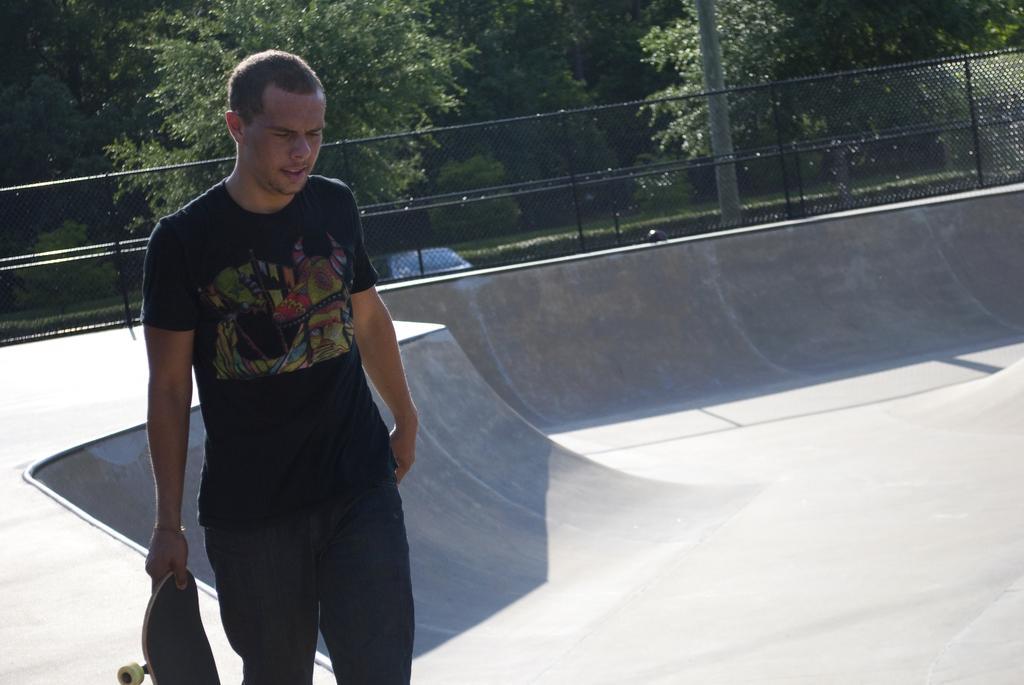Please provide a concise description of this image. In this image there is a man walking on the ground. He is holding a skateboard in his hand. Behind him there is a net. In the background there are trees and poles. To the right there is a slope on the ground. 